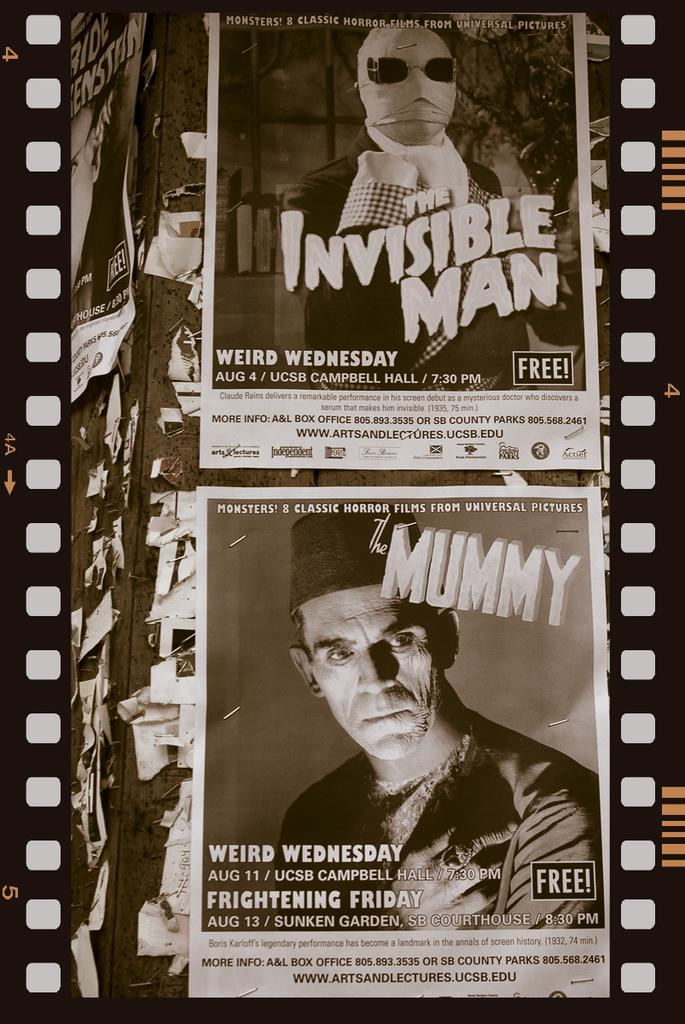What can be seen on the wall in the image? There are posts on the wall in the image. What is depicted on the posts? The posts have images on them. What else can be found on the posts? The posts have text on them. What type of wrist support is visible in the image? There is no wrist support present in the image; the image features posts with images and text on them. 